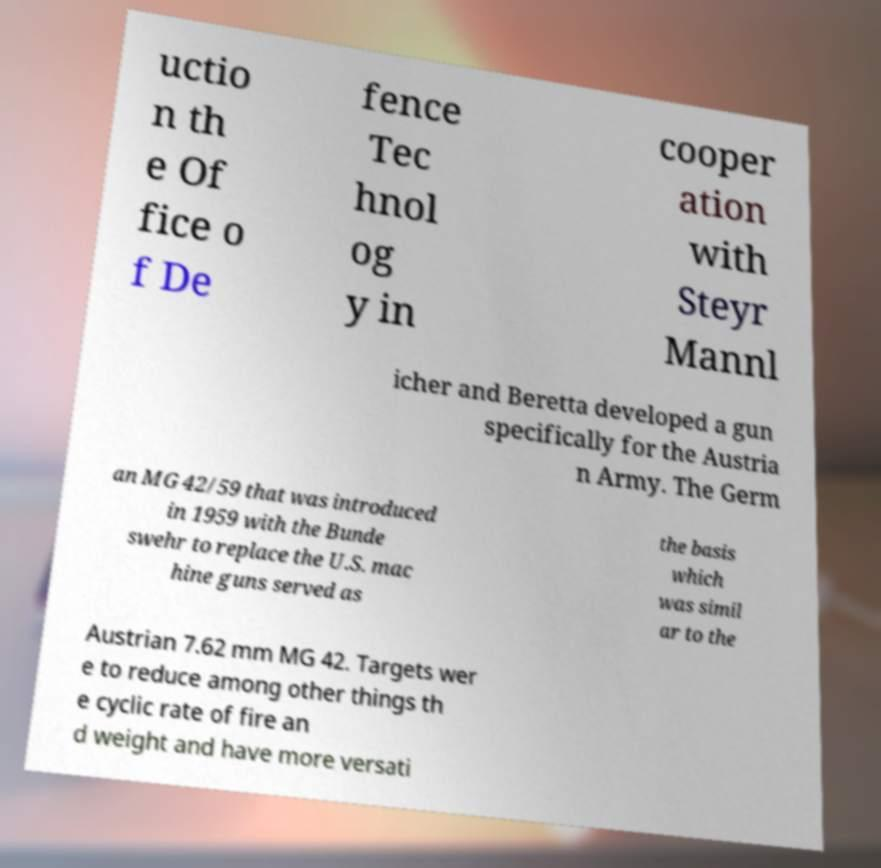Please read and relay the text visible in this image. What does it say? uctio n th e Of fice o f De fence Tec hnol og y in cooper ation with Steyr Mannl icher and Beretta developed a gun specifically for the Austria n Army. The Germ an MG 42/59 that was introduced in 1959 with the Bunde swehr to replace the U.S. mac hine guns served as the basis which was simil ar to the Austrian 7.62 mm MG 42. Targets wer e to reduce among other things th e cyclic rate of fire an d weight and have more versati 